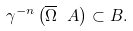Convert formula to latex. <formula><loc_0><loc_0><loc_500><loc_500>\gamma ^ { - n } \left ( \overline { \Omega } \ A \right ) \subset B .</formula> 